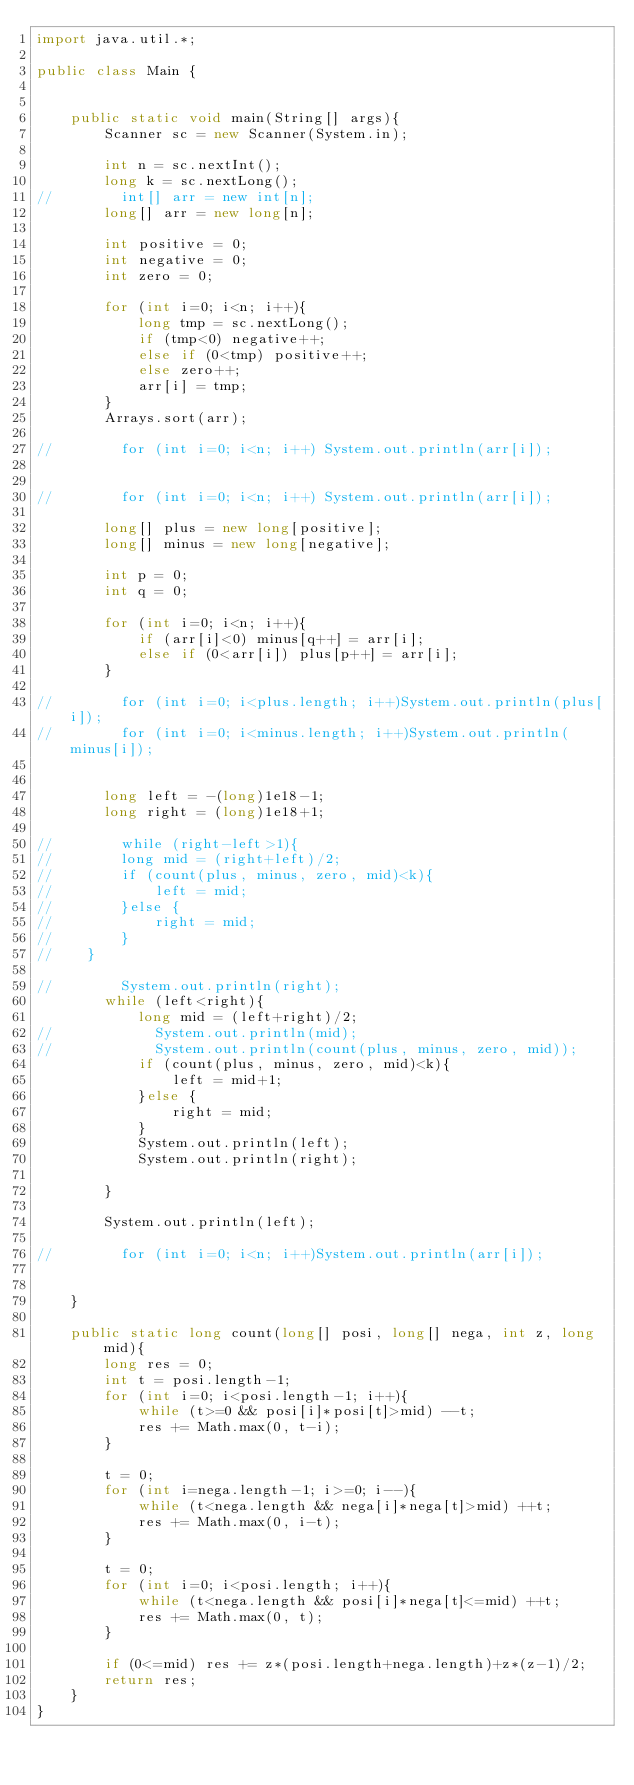Convert code to text. <code><loc_0><loc_0><loc_500><loc_500><_Java_>import java.util.*;

public class Main {


    public static void main(String[] args){
        Scanner sc = new Scanner(System.in);

        int n = sc.nextInt();
        long k = sc.nextLong();
//        int[] arr = new int[n];
        long[] arr = new long[n];

        int positive = 0;
        int negative = 0;
        int zero = 0;

        for (int i=0; i<n; i++){
            long tmp = sc.nextLong();
            if (tmp<0) negative++;
            else if (0<tmp) positive++;
            else zero++;
            arr[i] = tmp;
        }
        Arrays.sort(arr);

//        for (int i=0; i<n; i++) System.out.println(arr[i]);


//        for (int i=0; i<n; i++) System.out.println(arr[i]);

        long[] plus = new long[positive];
        long[] minus = new long[negative];

        int p = 0;
        int q = 0;

        for (int i=0; i<n; i++){
            if (arr[i]<0) minus[q++] = arr[i];
            else if (0<arr[i]) plus[p++] = arr[i];
        }

//        for (int i=0; i<plus.length; i++)System.out.println(plus[i]);
//        for (int i=0; i<minus.length; i++)System.out.println(minus[i]);


        long left = -(long)1e18-1;
        long right = (long)1e18+1;

//        while (right-left>1){
//        long mid = (right+left)/2;
//        if (count(plus, minus, zero, mid)<k){
//            left = mid;
//        }else {
//            right = mid;
//        }
//    }

//        System.out.println(right);
        while (left<right){
            long mid = (left+right)/2;
//            System.out.println(mid);
//            System.out.println(count(plus, minus, zero, mid));
            if (count(plus, minus, zero, mid)<k){
                left = mid+1;
            }else {
                right = mid;
            }
            System.out.println(left);
            System.out.println(right);

        }

        System.out.println(left);

//        for (int i=0; i<n; i++)System.out.println(arr[i]);


    }

    public static long count(long[] posi, long[] nega, int z, long mid){
        long res = 0;
        int t = posi.length-1;
        for (int i=0; i<posi.length-1; i++){
            while (t>=0 && posi[i]*posi[t]>mid) --t;
            res += Math.max(0, t-i);
        }

        t = 0;
        for (int i=nega.length-1; i>=0; i--){
            while (t<nega.length && nega[i]*nega[t]>mid) ++t;
            res += Math.max(0, i-t);
        }

        t = 0;
        for (int i=0; i<posi.length; i++){
            while (t<nega.length && posi[i]*nega[t]<=mid) ++t;
            res += Math.max(0, t);
        }

        if (0<=mid) res += z*(posi.length+nega.length)+z*(z-1)/2;
        return res;
    }
}

</code> 